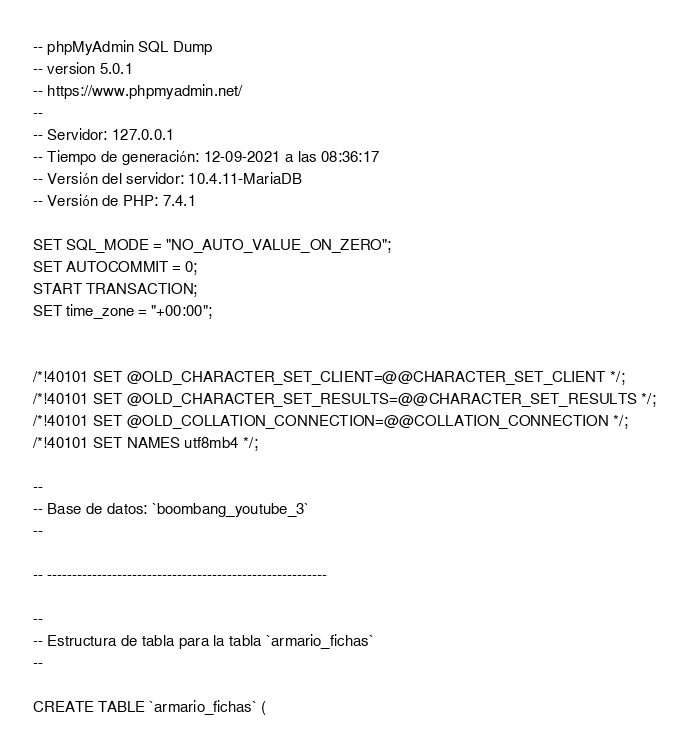<code> <loc_0><loc_0><loc_500><loc_500><_SQL_>-- phpMyAdmin SQL Dump
-- version 5.0.1
-- https://www.phpmyadmin.net/
--
-- Servidor: 127.0.0.1
-- Tiempo de generación: 12-09-2021 a las 08:36:17
-- Versión del servidor: 10.4.11-MariaDB
-- Versión de PHP: 7.4.1

SET SQL_MODE = "NO_AUTO_VALUE_ON_ZERO";
SET AUTOCOMMIT = 0;
START TRANSACTION;
SET time_zone = "+00:00";


/*!40101 SET @OLD_CHARACTER_SET_CLIENT=@@CHARACTER_SET_CLIENT */;
/*!40101 SET @OLD_CHARACTER_SET_RESULTS=@@CHARACTER_SET_RESULTS */;
/*!40101 SET @OLD_COLLATION_CONNECTION=@@COLLATION_CONNECTION */;
/*!40101 SET NAMES utf8mb4 */;

--
-- Base de datos: `boombang_youtube_3`
--

-- --------------------------------------------------------

--
-- Estructura de tabla para la tabla `armario_fichas`
--

CREATE TABLE `armario_fichas` (</code> 